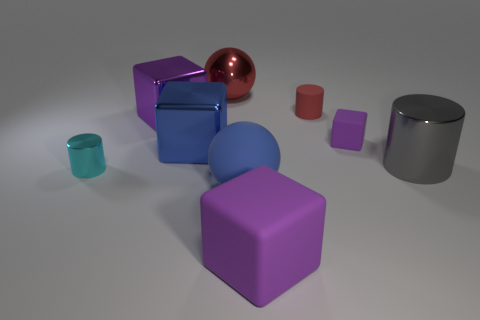Subtract all small matte cubes. How many cubes are left? 3 Subtract all red cylinders. How many cylinders are left? 2 Subtract all cylinders. How many objects are left? 6 Subtract 0 yellow blocks. How many objects are left? 9 Subtract 3 cylinders. How many cylinders are left? 0 Subtract all blue cylinders. Subtract all green spheres. How many cylinders are left? 3 Subtract all green balls. How many gray cubes are left? 0 Subtract all tiny purple rubber blocks. Subtract all large metal objects. How many objects are left? 4 Add 4 red objects. How many red objects are left? 6 Add 4 large red things. How many large red things exist? 5 